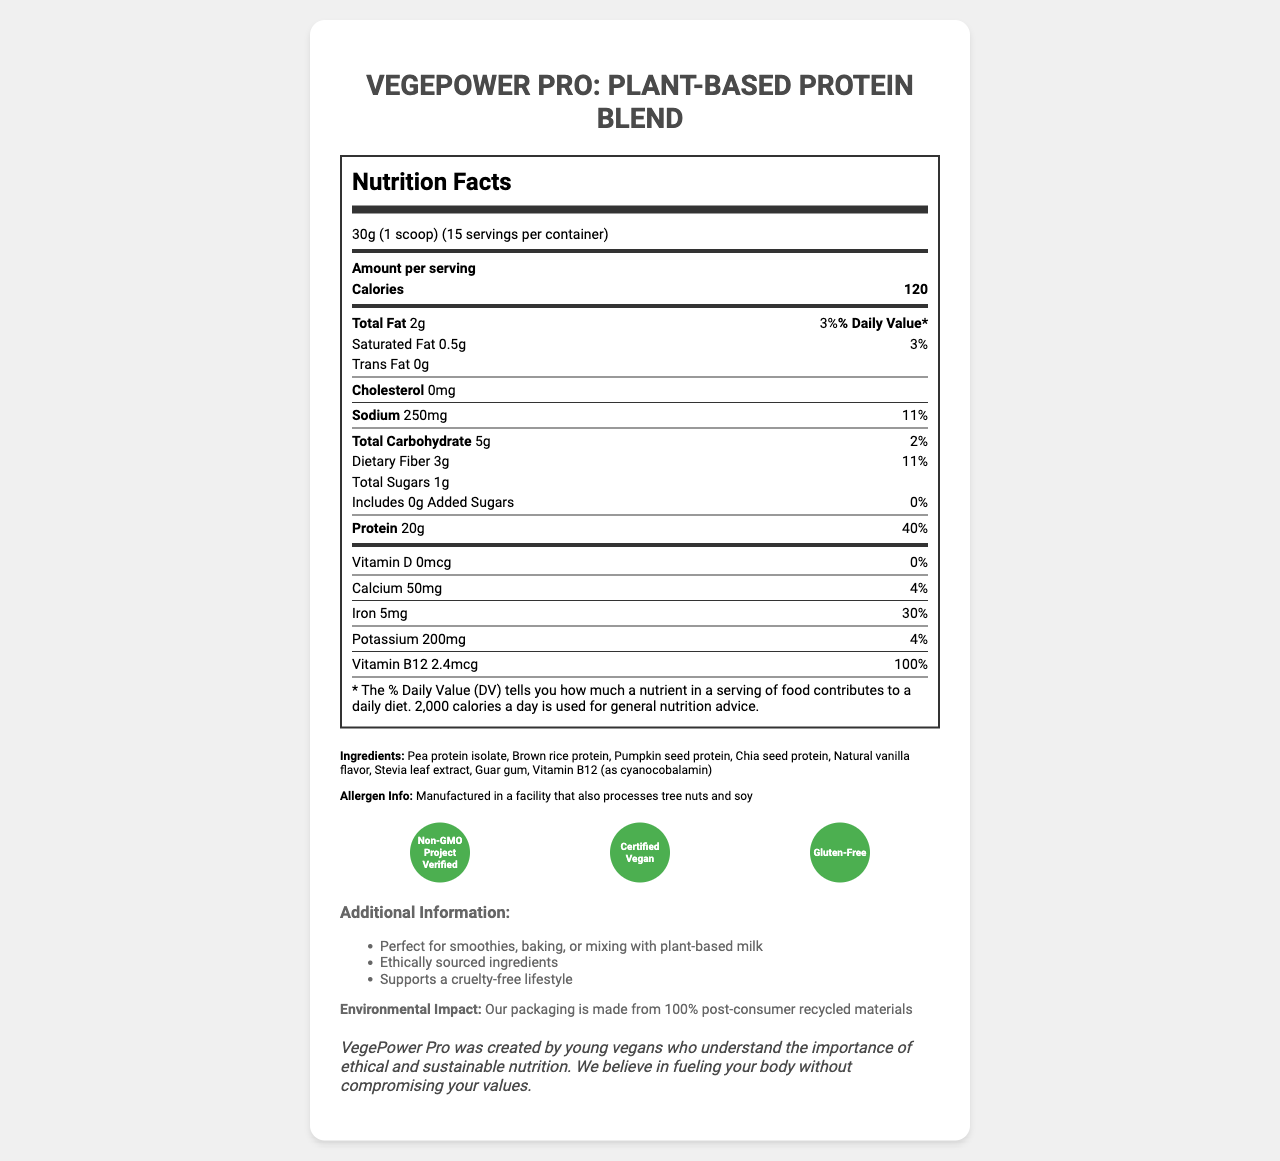what is the product name? The product name is titled at the top of the document.
Answer: VegePower Pro: Plant-Based Protein Blend what is the serving size for VegePower Pro? The document states "serving size" as 30g (1 scoop).
Answer: 30g (1 scoop) how many servings are in each container? The document specifies that there are 15 servings per container.
Answer: 15 how many calories does one serving provide? The document lists the calories per serving as 120.
Answer: 120 how much protein is in each serving? The protein content per serving is mentioned as 20g.
Answer: 20g what percentage of the daily value is the sodium content? A. 5% B. 8% C. 11% The sodium content has a daily value of 11%, as stated in the document.
Answer: C what are the sources of protein in VegePower Pro? A. Soy protein B. Pea protein isolate C. Whey protein D. Brown rice protein The document lists "Pea protein isolate" and "Brown rice protein" as ingredients.
Answer: B, D does VegePower Pro contain any cholesterol? The document specifies "cholesterol: 0mg".
Answer: No describe the allergen information for VegePower Pro. The allergen information section mentions that it is manufactured in a facility that processes tree nuts and soy.
Answer: Manufactured in a facility that also processes tree nuts and soy what is the environmental impact of VegePower Pro's packaging? The document mentions that the packaging uses 100% post-consumer recycled materials.
Answer: The packaging is made from 100% post-consumer recycled materials which nutrient has a daily value percentage of 40% in VegePower Pro? The document shows that protein has a daily value of 40%.
Answer: Protein does the document mention the taste or flavor of VegePower Pro? Among the ingredients, "Natural vanilla flavor" is listed, indicating the flavor.
Answer: Yes, Natural vanilla flavor how much iron is provided in each serving? The document shows that each serving contains 5mg of iron.
Answer: 5mg what certifications does VegePower Pro have? A. Non-GMO Project Verified B. USDA Organic C. Certified Vegan D. Gluten-Free The document lists Non-GMO Project Verified, Certified Vegan, and Gluten-Free as certifications.
Answer: A, C, D is Stevia used as a sweetener in VegePower Pro? Stevia leaf extract is listed as one of the ingredients.
Answer: Yes what is the purpose mentioned for Vitamin B12 in VegePower Pro? The document lists Vitamin B12 as an ingredient but does not specify its purpose.
Answer: Not enough information explain the additional information provided about VegePower Pro. This information is listed under the additional information section.
Answer: The product is perfect for smoothies, baking, or mixing with plant-based milk. It uses ethically sourced ingredients and supports a cruelty-free lifestyle. 